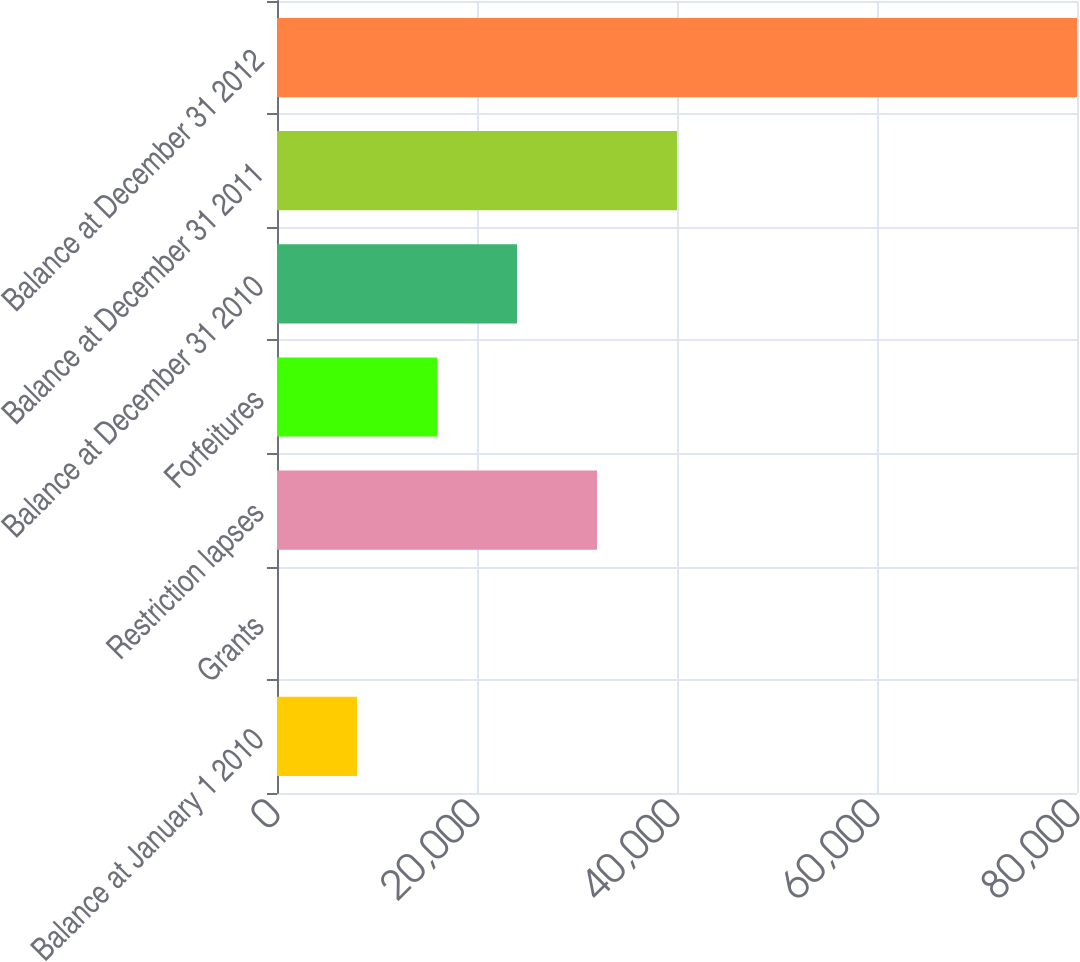Convert chart to OTSL. <chart><loc_0><loc_0><loc_500><loc_500><bar_chart><fcel>Balance at January 1 2010<fcel>Grants<fcel>Restriction lapses<fcel>Forfeitures<fcel>Balance at December 31 2010<fcel>Balance at December 31 2011<fcel>Balance at December 31 2012<nl><fcel>8001.54<fcel>1.71<fcel>32001<fcel>16001.4<fcel>24001.2<fcel>40000.9<fcel>80000<nl></chart> 